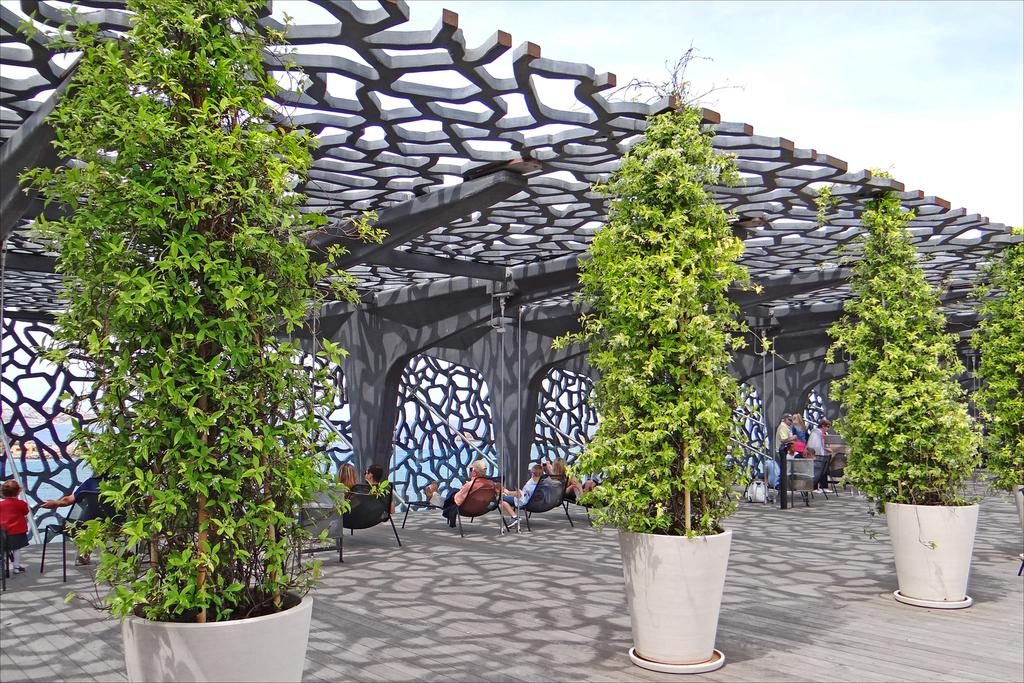What type of vegetation can be seen in the image? There are trees in the image. What objects are present in the image that might be used for planting? There are pots in the image that can be used for planting. What are the people in the image doing? The people in the image are sitting on chairs. What can be found on the ground in the image? There are objects on the ground in the image. What is visible in the background of the image? The sky is visible in the background of the image. What type of marble is being used to create the chairs in the image? There is no mention of marble or chairs being made of marble in the image. What drug is being distributed by the people sitting on chairs in the image? There is no indication of any drug-related activity in the image. 